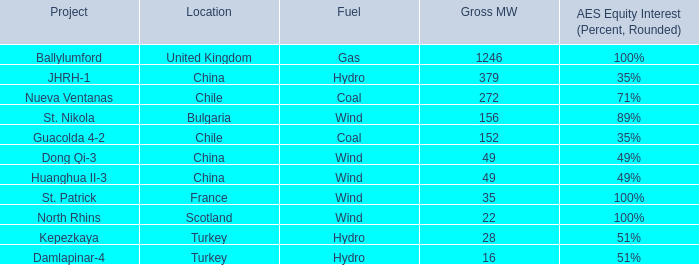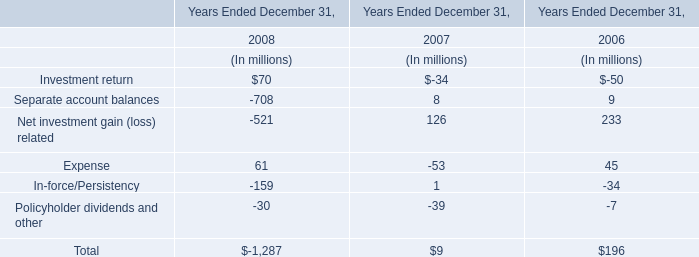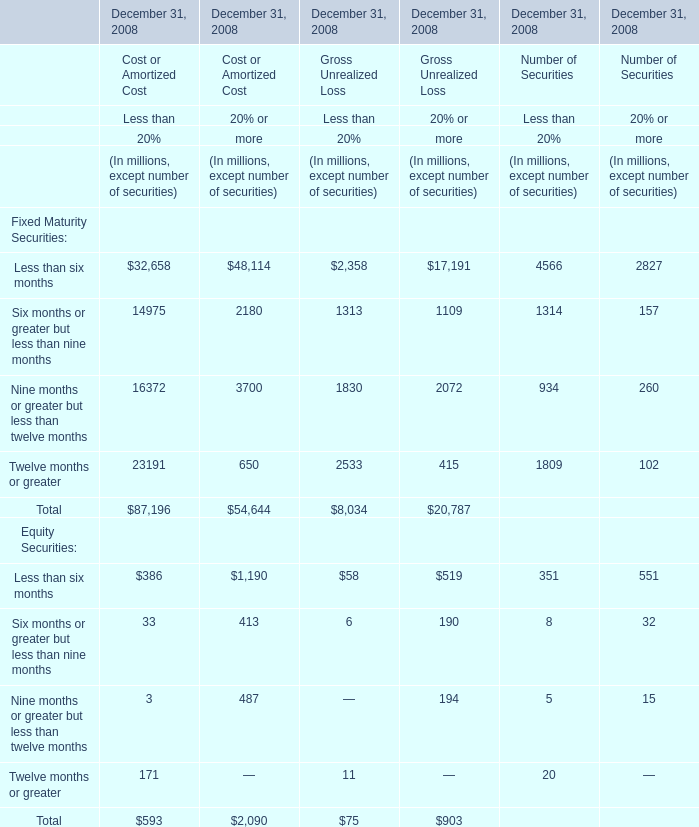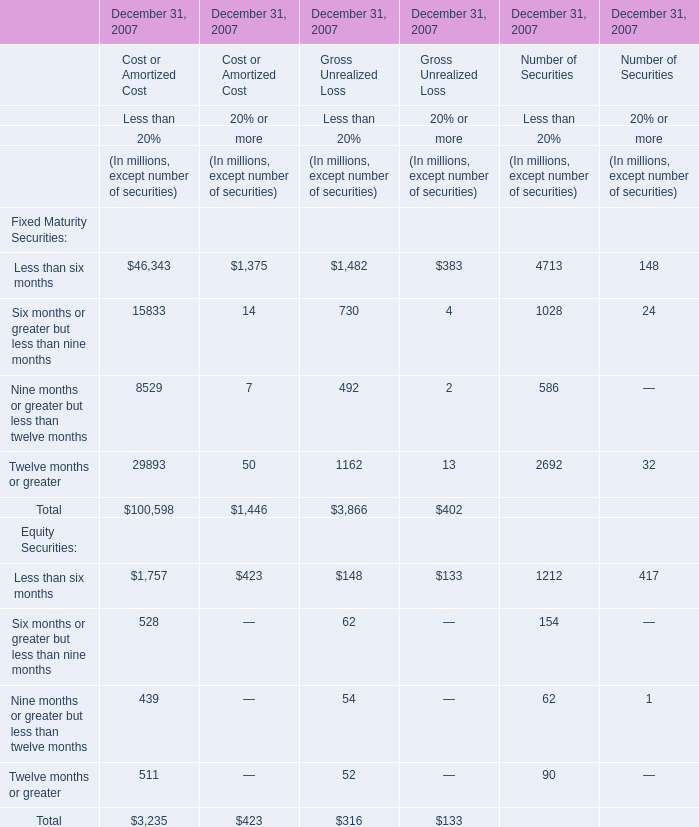what percentage of mw from acquired or commenced commercial operations in 2010 were due to nueva ventana? 
Computations: (272 / 2404)
Answer: 0.11314. 